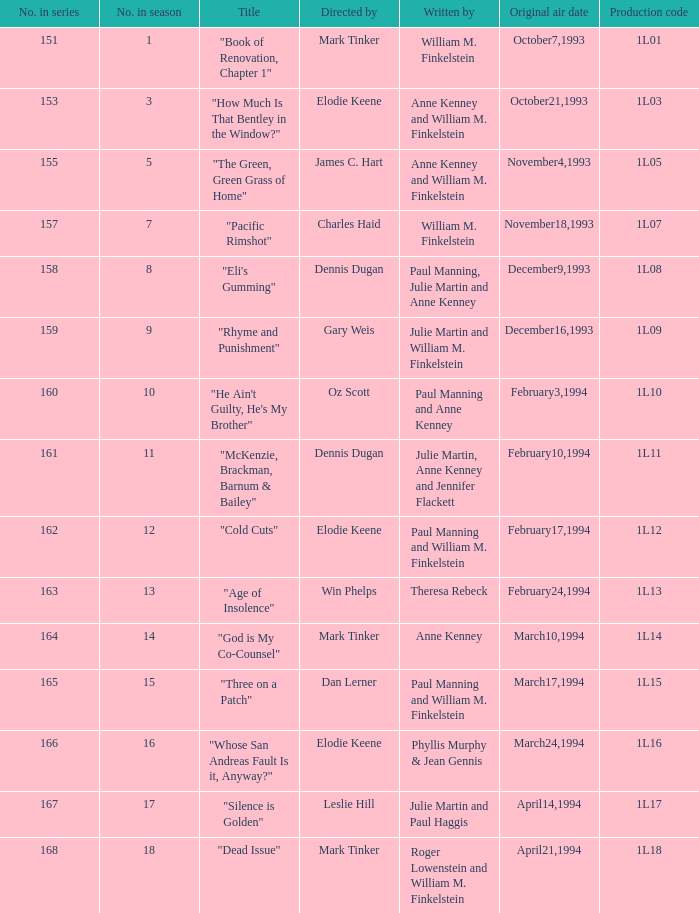Can you parse all the data within this table? {'header': ['No. in series', 'No. in season', 'Title', 'Directed by', 'Written by', 'Original air date', 'Production code'], 'rows': [['151', '1', '"Book of Renovation, Chapter 1"', 'Mark Tinker', 'William M. Finkelstein', 'October7,1993', '1L01'], ['153', '3', '"How Much Is That Bentley in the Window?"', 'Elodie Keene', 'Anne Kenney and William M. Finkelstein', 'October21,1993', '1L03'], ['155', '5', '"The Green, Green Grass of Home"', 'James C. Hart', 'Anne Kenney and William M. Finkelstein', 'November4,1993', '1L05'], ['157', '7', '"Pacific Rimshot"', 'Charles Haid', 'William M. Finkelstein', 'November18,1993', '1L07'], ['158', '8', '"Eli\'s Gumming"', 'Dennis Dugan', 'Paul Manning, Julie Martin and Anne Kenney', 'December9,1993', '1L08'], ['159', '9', '"Rhyme and Punishment"', 'Gary Weis', 'Julie Martin and William M. Finkelstein', 'December16,1993', '1L09'], ['160', '10', '"He Ain\'t Guilty, He\'s My Brother"', 'Oz Scott', 'Paul Manning and Anne Kenney', 'February3,1994', '1L10'], ['161', '11', '"McKenzie, Brackman, Barnum & Bailey"', 'Dennis Dugan', 'Julie Martin, Anne Kenney and Jennifer Flackett', 'February10,1994', '1L11'], ['162', '12', '"Cold Cuts"', 'Elodie Keene', 'Paul Manning and William M. Finkelstein', 'February17,1994', '1L12'], ['163', '13', '"Age of Insolence"', 'Win Phelps', 'Theresa Rebeck', 'February24,1994', '1L13'], ['164', '14', '"God is My Co-Counsel"', 'Mark Tinker', 'Anne Kenney', 'March10,1994', '1L14'], ['165', '15', '"Three on a Patch"', 'Dan Lerner', 'Paul Manning and William M. Finkelstein', 'March17,1994', '1L15'], ['166', '16', '"Whose San Andreas Fault Is it, Anyway?"', 'Elodie Keene', 'Phyllis Murphy & Jean Gennis', 'March24,1994', '1L16'], ['167', '17', '"Silence is Golden"', 'Leslie Hill', 'Julie Martin and Paul Haggis', 'April14,1994', '1L17'], ['168', '18', '"Dead Issue"', 'Mark Tinker', 'Roger Lowenstein and William M. Finkelstein', 'April21,1994', '1L18']]} Name the production code for theresa rebeck 1L13. 